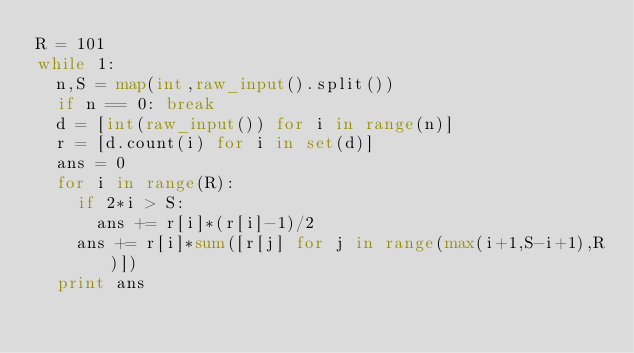Convert code to text. <code><loc_0><loc_0><loc_500><loc_500><_Python_>R = 101
while 1:
	n,S = map(int,raw_input().split())
	if n == 0: break
	d = [int(raw_input()) for i in range(n)]
	r = [d.count(i) for i in set(d)]
	ans = 0
	for i in range(R):
		if 2*i > S:
			ans += r[i]*(r[i]-1)/2
		ans += r[i]*sum([r[j] for j in range(max(i+1,S-i+1),R)])
	print ans</code> 